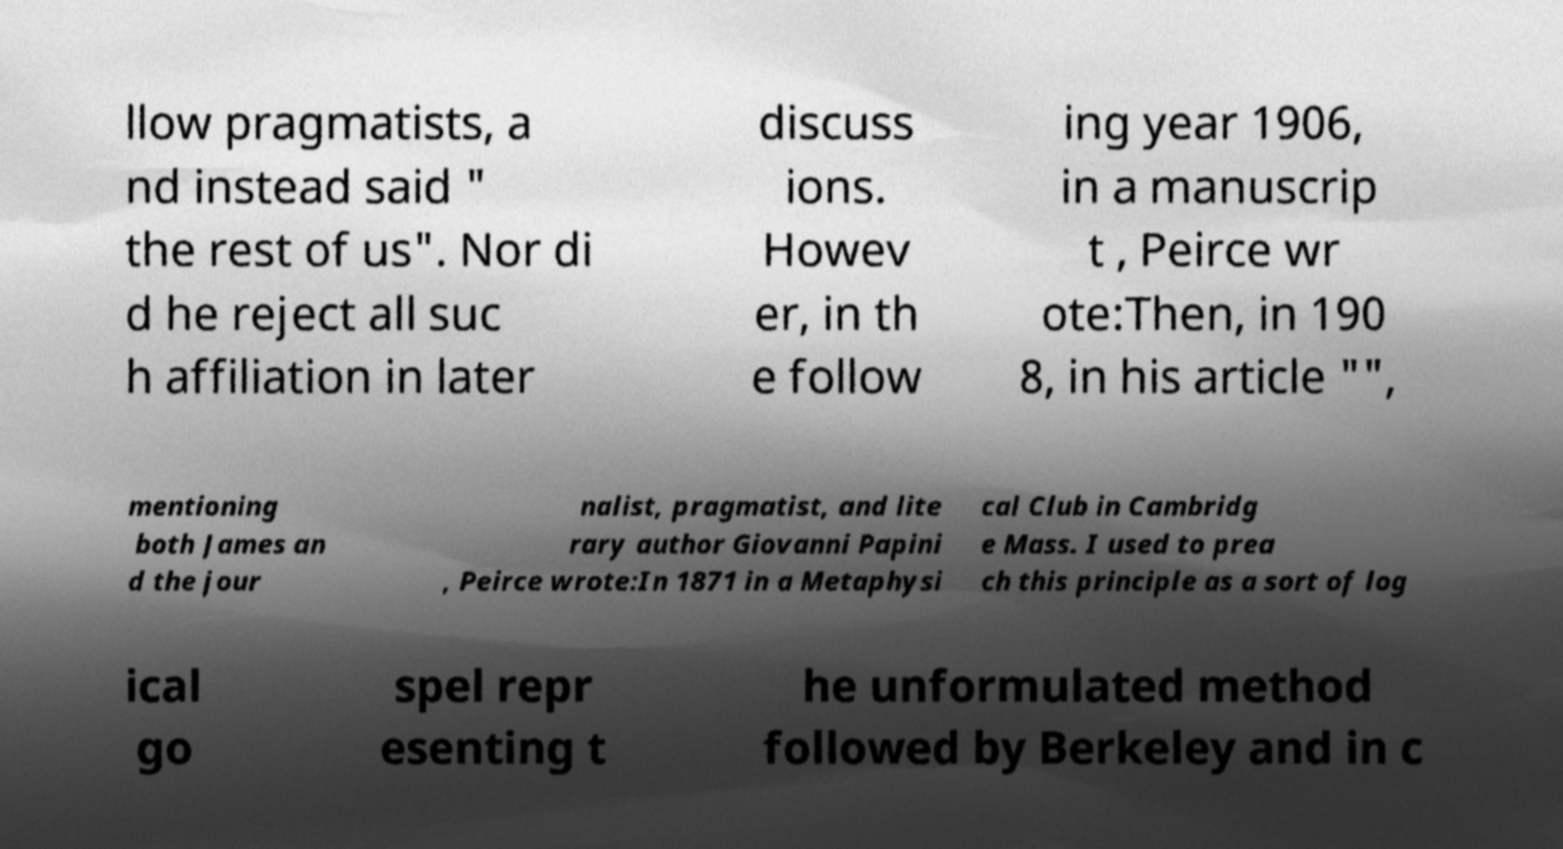Please identify and transcribe the text found in this image. llow pragmatists, a nd instead said " the rest of us". Nor di d he reject all suc h affiliation in later discuss ions. Howev er, in th e follow ing year 1906, in a manuscrip t , Peirce wr ote:Then, in 190 8, in his article "", mentioning both James an d the jour nalist, pragmatist, and lite rary author Giovanni Papini , Peirce wrote:In 1871 in a Metaphysi cal Club in Cambridg e Mass. I used to prea ch this principle as a sort of log ical go spel repr esenting t he unformulated method followed by Berkeley and in c 